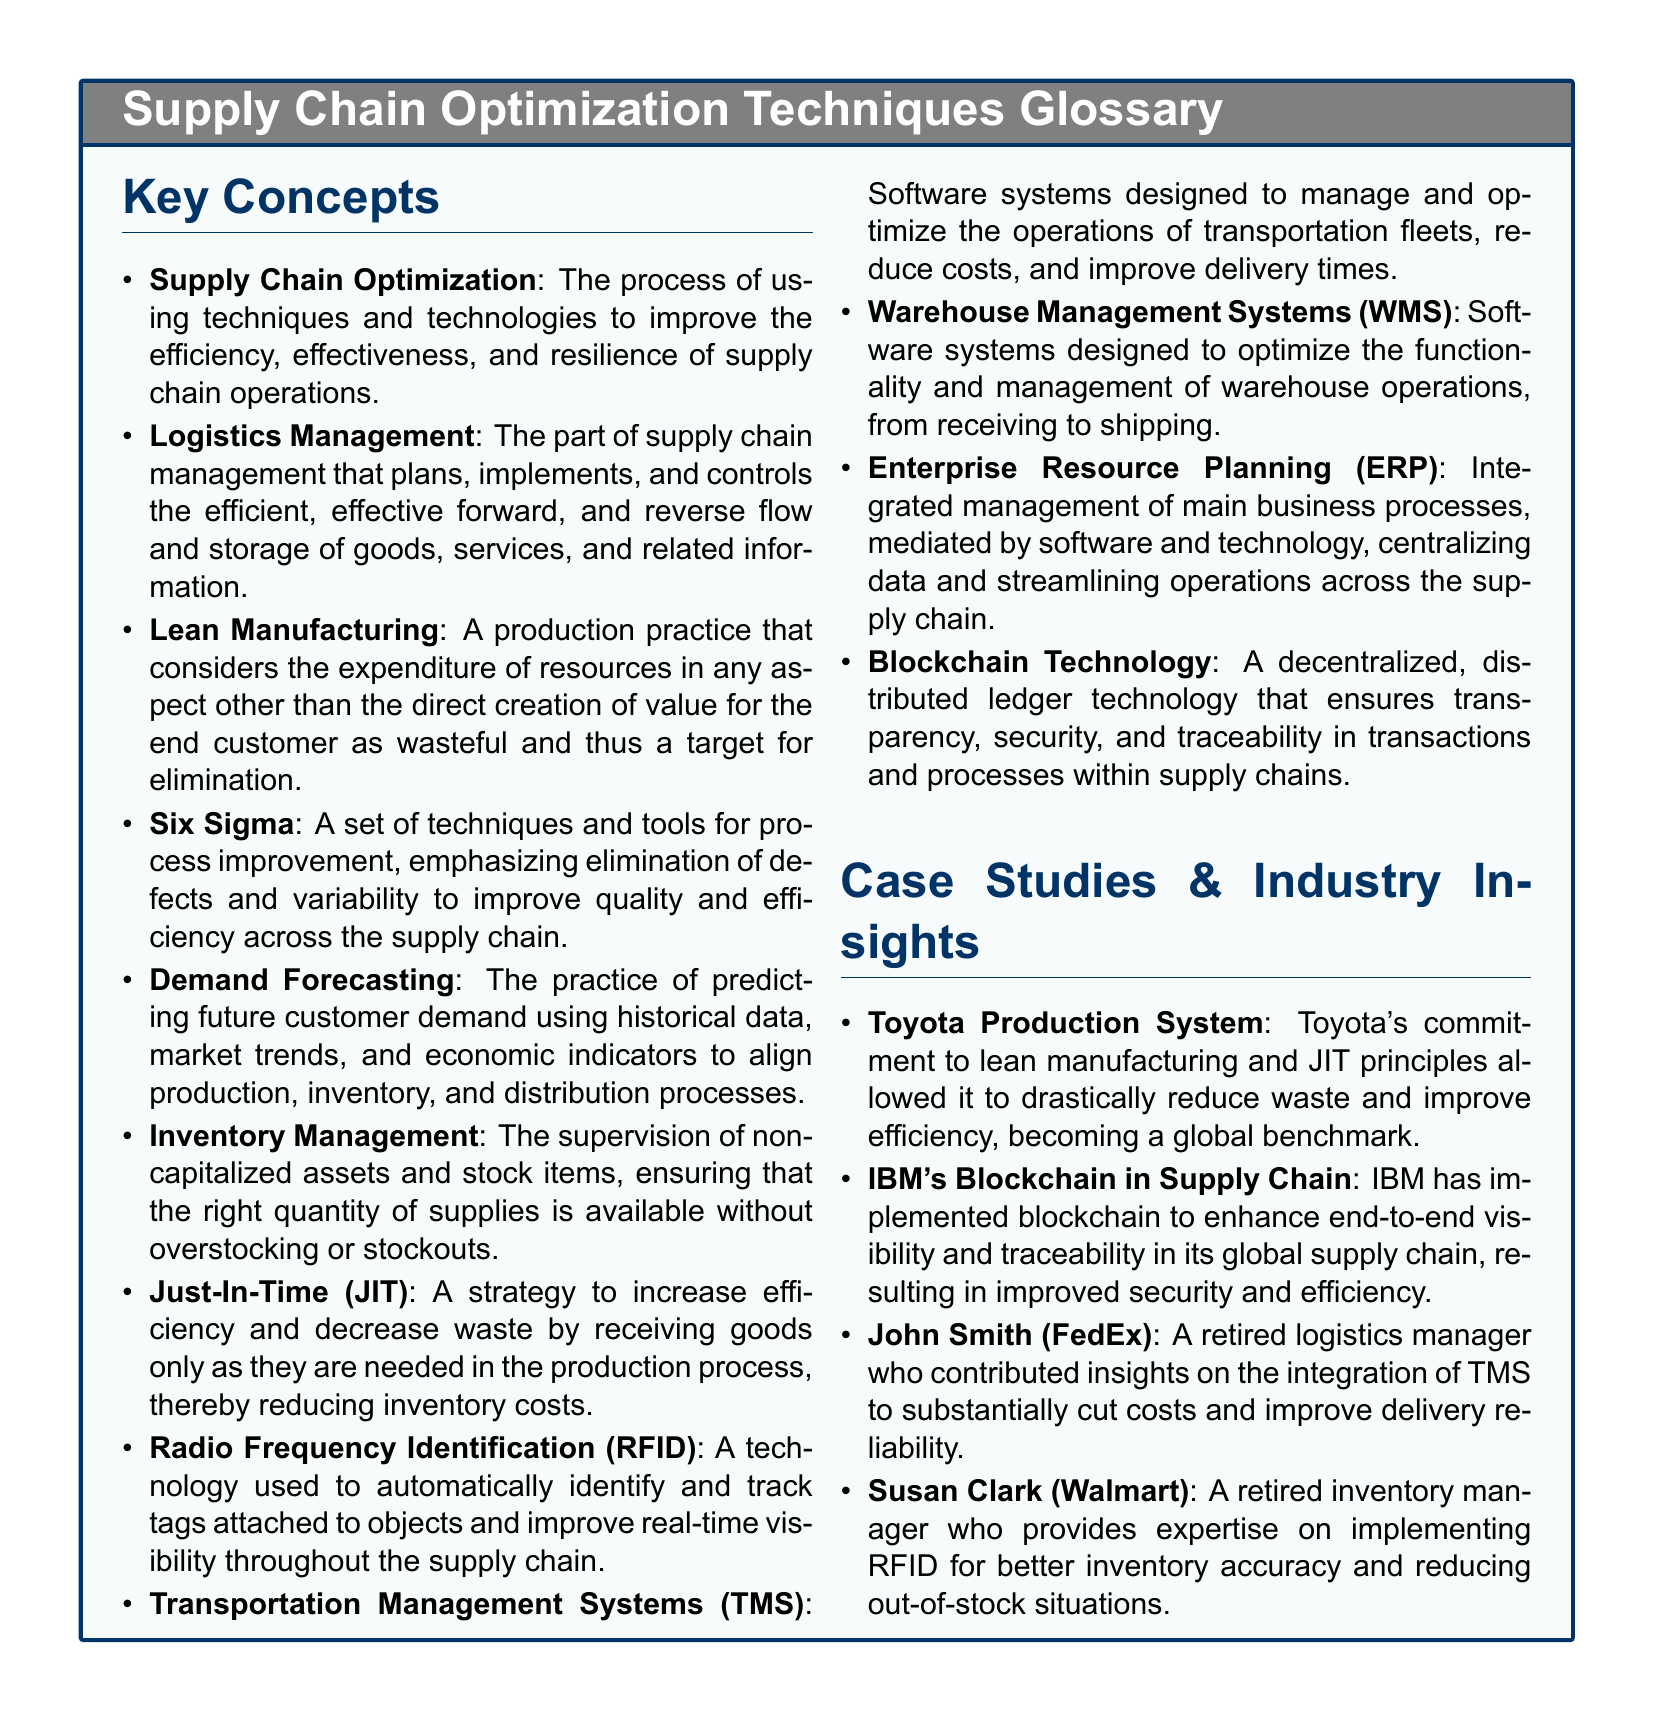What is the main purpose of supply chain optimization? Supply chain optimization aims to improve the efficiency, effectiveness, and resilience of supply chain operations.
Answer: To improve efficiency, effectiveness, and resilience What technology is used to track objects in real-time? Radio Frequency Identification is a technology used to automatically identify and track tags attached to objects.
Answer: Radio Frequency Identification (RFID) Who is a retired logistics manager that contributed insights on TMS? John Smith is mentioned as a retired logistics manager who provided insights on TMS.
Answer: John Smith What manufacturing practice targets resource expenditure as waste? Lean manufacturing considers the expenditure of resources in any aspect other than value creation as wasteful.
Answer: Lean Manufacturing Which company's production system is a global benchmark for efficiency? Toyota's Production System is noted as a global benchmark for efficiency.
Answer: Toyota Production System What system manages and optimizes transportation operations? Transportation Management Systems are designed to manage and optimize transportation operations.
Answer: Transportation Management Systems (TMS) Who provided expertise on implementing RFID for inventory accuracy? Susan Clark, a retired inventory manager, provides expertise on implementing RFID.
Answer: Susan Clark What does ERP stand for in supply chain management? ERP stands for Enterprise Resource Planning, related to the management of business processes mediated by software.
Answer: Enterprise Resource Planning (ERP) What technology enhances end-to-end visibility in supply chains? IBM uses blockchain technology to enhance end-to-end visibility and traceability in its supply chain.
Answer: Blockchain Technology 